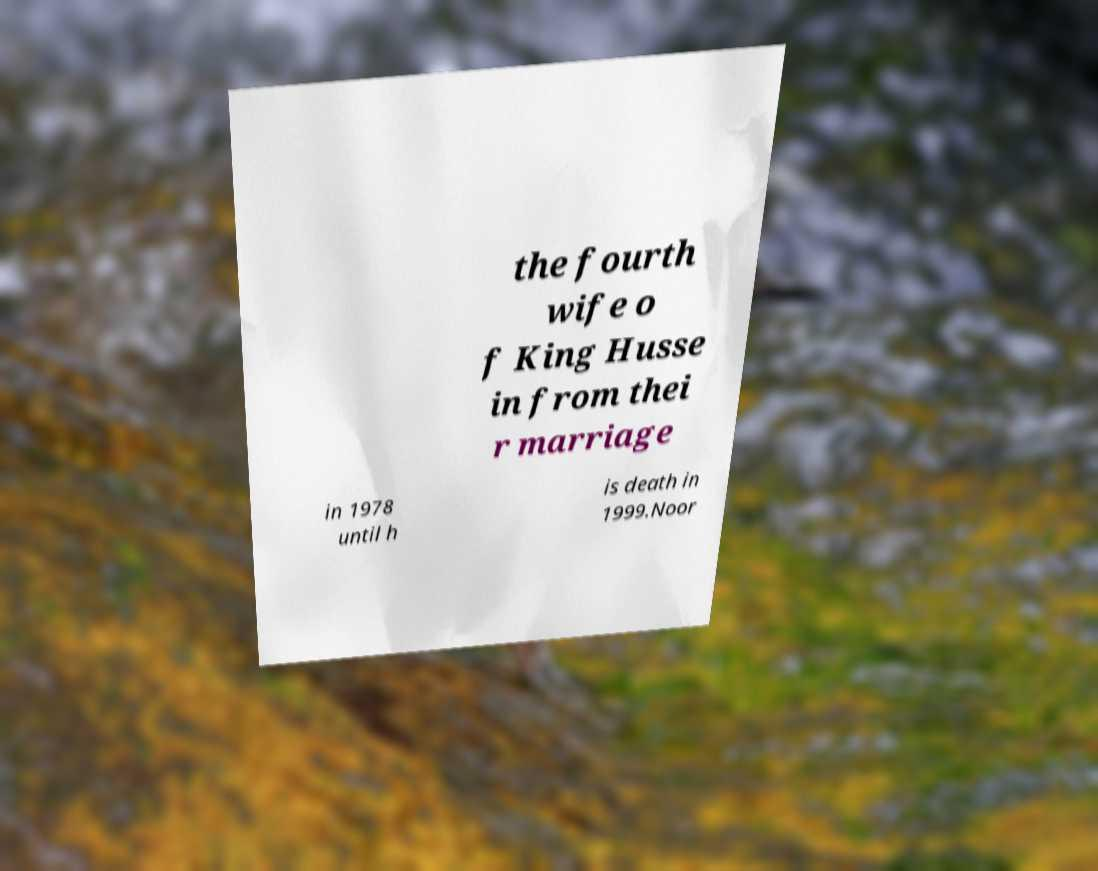There's text embedded in this image that I need extracted. Can you transcribe it verbatim? the fourth wife o f King Husse in from thei r marriage in 1978 until h is death in 1999.Noor 